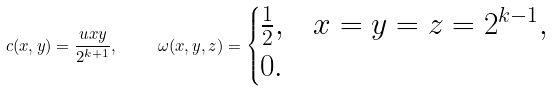<formula> <loc_0><loc_0><loc_500><loc_500>c ( x , y ) = \frac { u x y } { 2 ^ { k + 1 } } , \quad \ \omega ( x , y , z ) = \begin{cases} \frac { 1 } { 2 } , & x = y = z = 2 ^ { k - 1 } , \\ 0 . & \end{cases}</formula> 